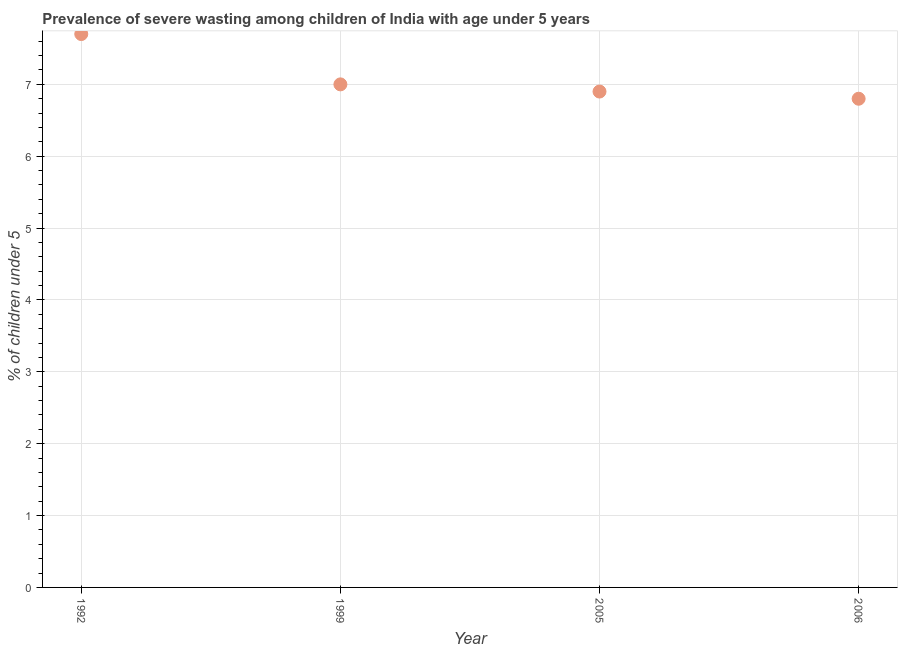What is the prevalence of severe wasting in 1992?
Your answer should be very brief. 7.7. Across all years, what is the maximum prevalence of severe wasting?
Offer a terse response. 7.7. Across all years, what is the minimum prevalence of severe wasting?
Ensure brevity in your answer.  6.8. In which year was the prevalence of severe wasting maximum?
Keep it short and to the point. 1992. What is the sum of the prevalence of severe wasting?
Provide a short and direct response. 28.4. What is the difference between the prevalence of severe wasting in 1992 and 2006?
Make the answer very short. 0.9. What is the average prevalence of severe wasting per year?
Provide a succinct answer. 7.1. What is the median prevalence of severe wasting?
Ensure brevity in your answer.  6.95. In how many years, is the prevalence of severe wasting greater than 5.4 %?
Keep it short and to the point. 4. Do a majority of the years between 1992 and 2006 (inclusive) have prevalence of severe wasting greater than 6.6 %?
Offer a terse response. Yes. What is the ratio of the prevalence of severe wasting in 1999 to that in 2006?
Your answer should be very brief. 1.03. Is the prevalence of severe wasting in 2005 less than that in 2006?
Ensure brevity in your answer.  No. What is the difference between the highest and the second highest prevalence of severe wasting?
Offer a terse response. 0.7. Is the sum of the prevalence of severe wasting in 1992 and 2006 greater than the maximum prevalence of severe wasting across all years?
Your answer should be compact. Yes. What is the difference between the highest and the lowest prevalence of severe wasting?
Provide a succinct answer. 0.9. Does the prevalence of severe wasting monotonically increase over the years?
Ensure brevity in your answer.  No. How many dotlines are there?
Give a very brief answer. 1. Does the graph contain any zero values?
Provide a short and direct response. No. What is the title of the graph?
Offer a terse response. Prevalence of severe wasting among children of India with age under 5 years. What is the label or title of the Y-axis?
Keep it short and to the point.  % of children under 5. What is the  % of children under 5 in 1992?
Your answer should be compact. 7.7. What is the  % of children under 5 in 1999?
Your answer should be compact. 7. What is the  % of children under 5 in 2005?
Keep it short and to the point. 6.9. What is the  % of children under 5 in 2006?
Provide a succinct answer. 6.8. What is the difference between the  % of children under 5 in 1992 and 2006?
Your answer should be very brief. 0.9. What is the difference between the  % of children under 5 in 1999 and 2005?
Offer a very short reply. 0.1. What is the difference between the  % of children under 5 in 1999 and 2006?
Ensure brevity in your answer.  0.2. What is the ratio of the  % of children under 5 in 1992 to that in 1999?
Keep it short and to the point. 1.1. What is the ratio of the  % of children under 5 in 1992 to that in 2005?
Provide a short and direct response. 1.12. What is the ratio of the  % of children under 5 in 1992 to that in 2006?
Make the answer very short. 1.13. What is the ratio of the  % of children under 5 in 1999 to that in 2005?
Give a very brief answer. 1.01. 